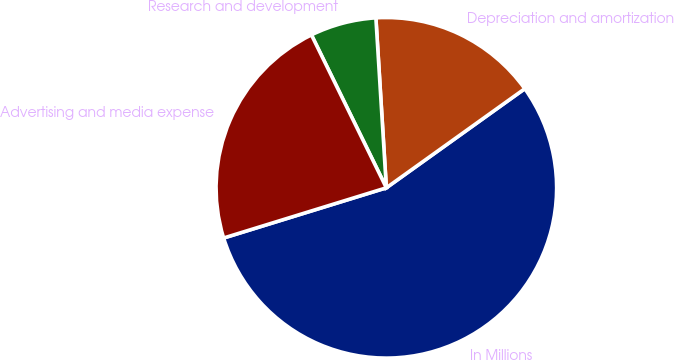<chart> <loc_0><loc_0><loc_500><loc_500><pie_chart><fcel>In Millions<fcel>Depreciation and amortization<fcel>Research and development<fcel>Advertising and media expense<nl><fcel>55.12%<fcel>16.09%<fcel>6.27%<fcel>22.51%<nl></chart> 